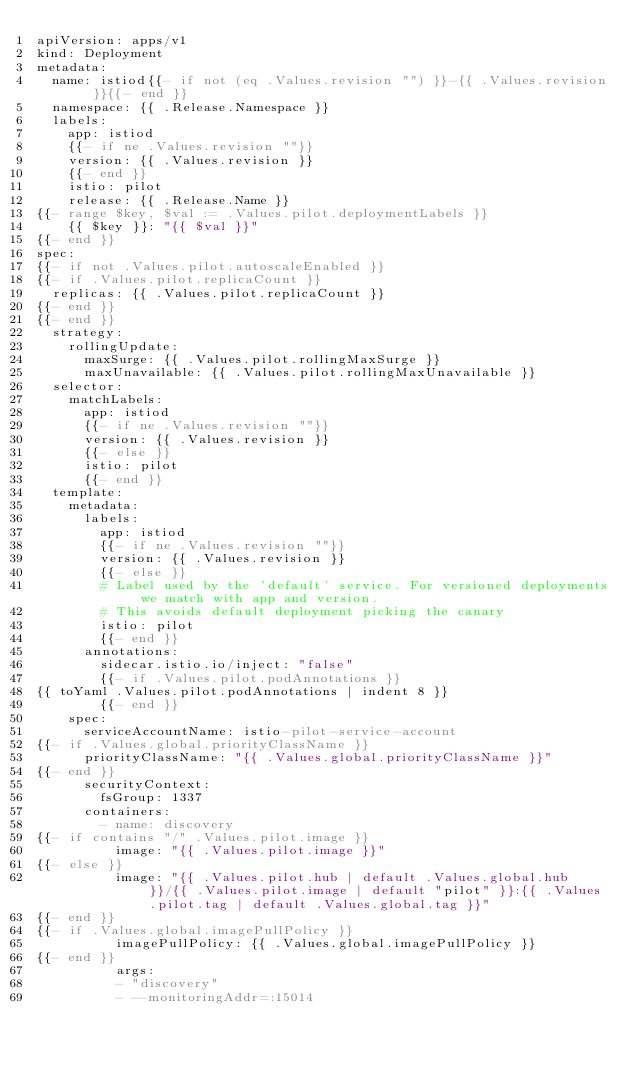<code> <loc_0><loc_0><loc_500><loc_500><_YAML_>apiVersion: apps/v1
kind: Deployment
metadata:
  name: istiod{{- if not (eq .Values.revision "") }}-{{ .Values.revision }}{{- end }}
  namespace: {{ .Release.Namespace }}
  labels:
    app: istiod
    {{- if ne .Values.revision ""}}
    version: {{ .Values.revision }}
    {{- end }}
    istio: pilot
    release: {{ .Release.Name }}
{{- range $key, $val := .Values.pilot.deploymentLabels }}
    {{ $key }}: "{{ $val }}"
{{- end }}
spec:
{{- if not .Values.pilot.autoscaleEnabled }}
{{- if .Values.pilot.replicaCount }}
  replicas: {{ .Values.pilot.replicaCount }}
{{- end }}
{{- end }}
  strategy:
    rollingUpdate:
      maxSurge: {{ .Values.pilot.rollingMaxSurge }}
      maxUnavailable: {{ .Values.pilot.rollingMaxUnavailable }}
  selector:
    matchLabels:
      app: istiod
      {{- if ne .Values.revision ""}}
      version: {{ .Values.revision }}
      {{- else }}
      istio: pilot
      {{- end }}
  template:
    metadata:
      labels:
        app: istiod
        {{- if ne .Values.revision ""}}
        version: {{ .Values.revision }}
        {{- else }}
        # Label used by the 'default' service. For versioned deployments we match with app and version.
        # This avoids default deployment picking the canary
        istio: pilot
        {{- end }}
      annotations:
        sidecar.istio.io/inject: "false"
        {{- if .Values.pilot.podAnnotations }}
{{ toYaml .Values.pilot.podAnnotations | indent 8 }}
        {{- end }}
    spec:
      serviceAccountName: istio-pilot-service-account
{{- if .Values.global.priorityClassName }}
      priorityClassName: "{{ .Values.global.priorityClassName }}"
{{- end }}
      securityContext:
        fsGroup: 1337
      containers:
        - name: discovery
{{- if contains "/" .Values.pilot.image }}
          image: "{{ .Values.pilot.image }}"
{{- else }}
          image: "{{ .Values.pilot.hub | default .Values.global.hub }}/{{ .Values.pilot.image | default "pilot" }}:{{ .Values.pilot.tag | default .Values.global.tag }}"
{{- end }}
{{- if .Values.global.imagePullPolicy }}
          imagePullPolicy: {{ .Values.global.imagePullPolicy }}
{{- end }}
          args:
          - "discovery"
          - --monitoringAddr=:15014</code> 